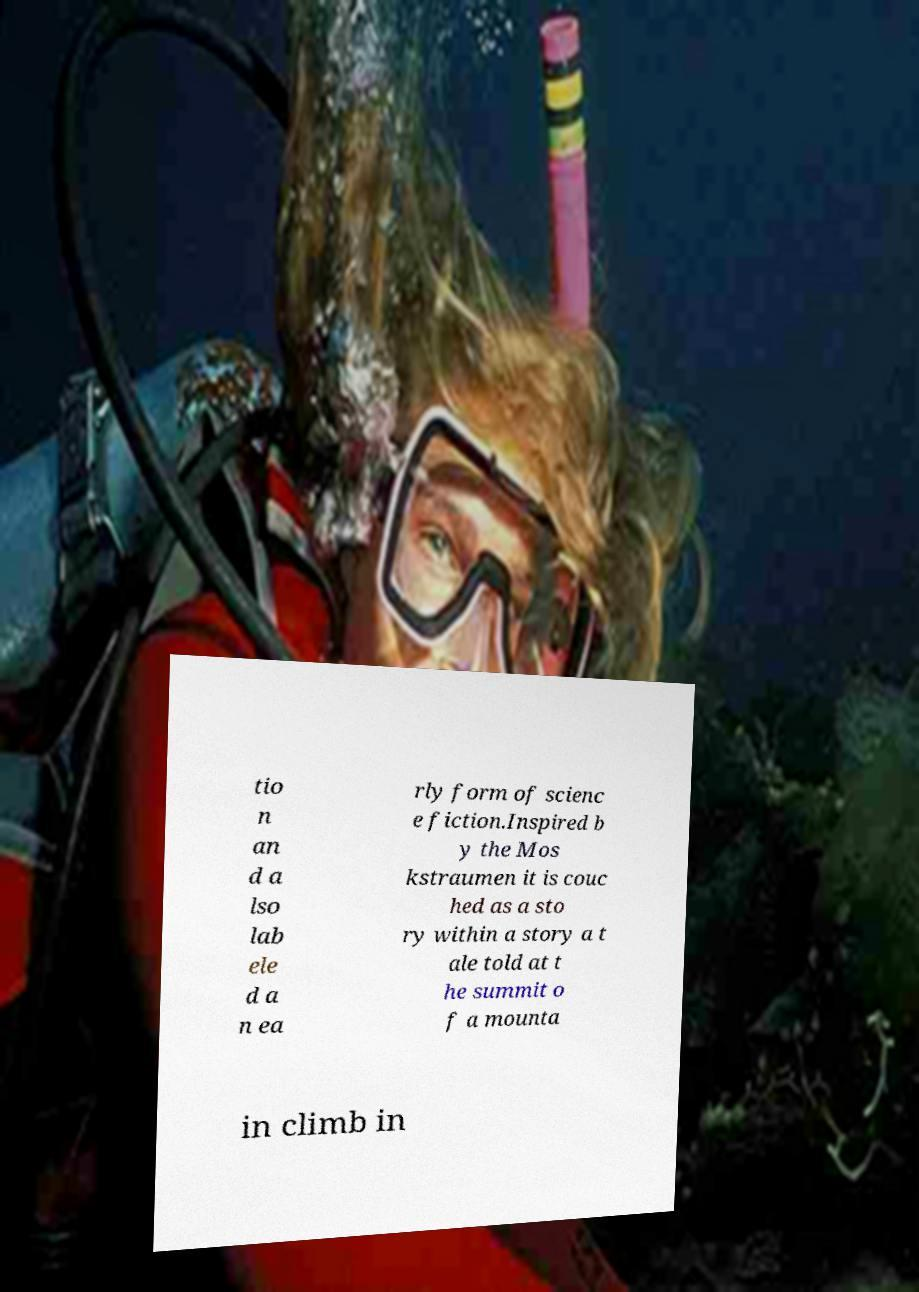Could you assist in decoding the text presented in this image and type it out clearly? tio n an d a lso lab ele d a n ea rly form of scienc e fiction.Inspired b y the Mos kstraumen it is couc hed as a sto ry within a story a t ale told at t he summit o f a mounta in climb in 